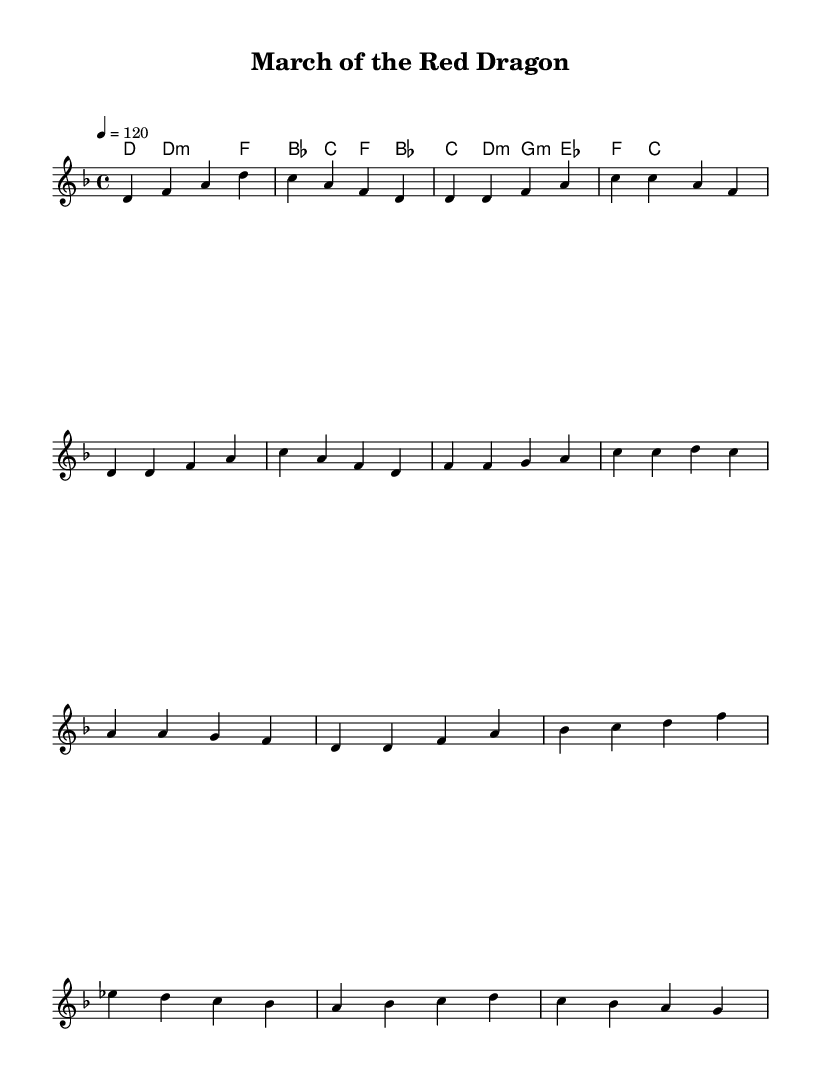what is the key signature of this music? The key signature indicated at the beginning of the piece shows two flat notes, which corresponds to D minor.
Answer: D minor what is the time signature of this music? The time signature is found at the beginning of the score and is represented by the fraction 4 over 4.
Answer: 4/4 what is the tempo marking of this piece? The tempo marking is indicated with "4 = 120", meaning there are 120 beats per minute, with a quarter note getting one beat.
Answer: 120 how many measures are in the chorus section? To find the number of measures in the chorus section, we can count the distinct measures in that part which is listed in the melody section. The chorus has four measures.
Answer: 4 what chords are used in the verse? Analyzing the chord mode section, the chords listed for the verse are D minor, F major, B flat major, and C major.
Answer: D minor, F, B flat, C which chord follows the melody notes of A in the chorus? Observing the melody line and its corresponding harmonic section during the chorus, A is followed by the chords C major and D minor, indicated in the harmony part.
Answer: C, D minor how does the bridge harmonically transition compared to the verse? The bridge switches to G minor, E flat major, and F major, differing from the verse which stays primarily in D minor and other major chords, showing a shift to a different harmonic structure.
Answer: G minor, E flat, F 